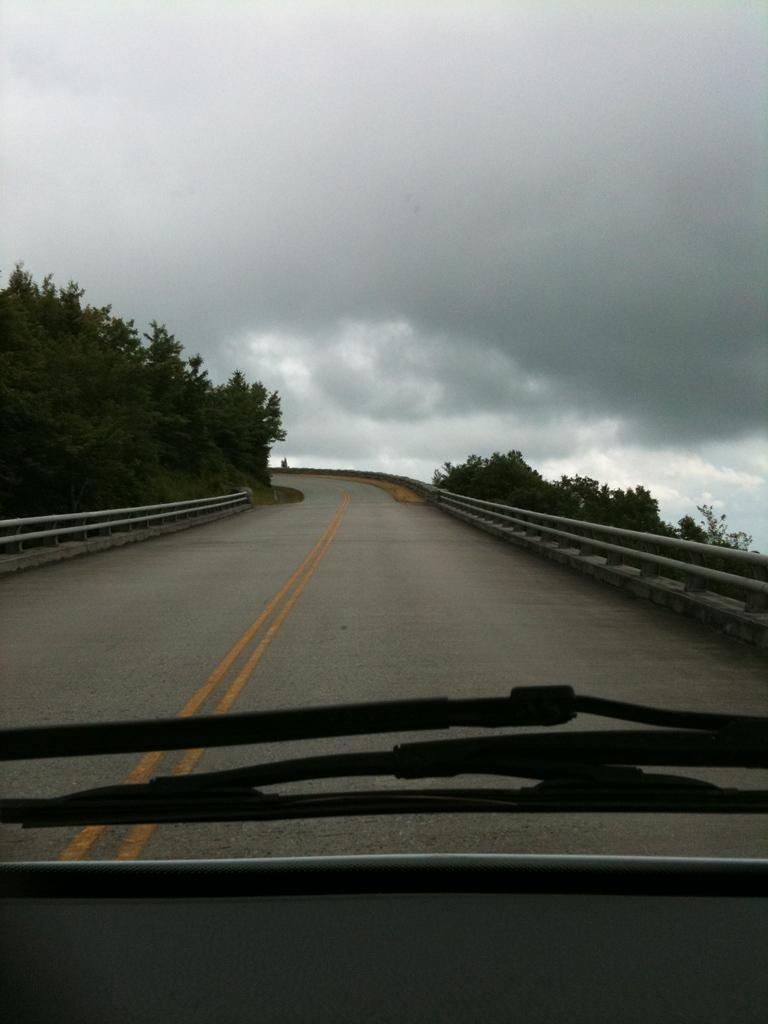In one or two sentences, can you explain what this image depicts? In this image we can see road, fencing there are some trees and in the background of the image we can see cloudy sky. 